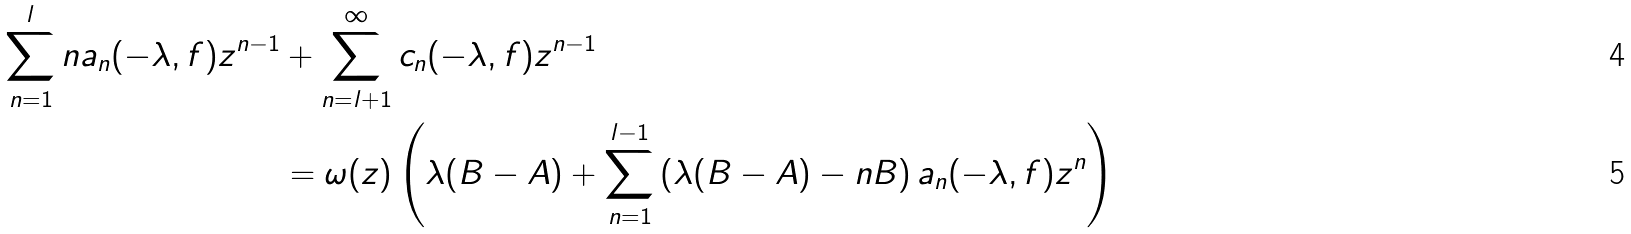<formula> <loc_0><loc_0><loc_500><loc_500>\sum _ { n = 1 } ^ { l } n a _ { n } ( - \lambda , f ) z ^ { n - 1 } & + \sum _ { n = l + 1 } ^ { \infty } c _ { n } ( - \lambda , f ) z ^ { n - 1 } \\ & = \omega ( z ) \left ( \lambda ( B - A ) + \sum _ { n = 1 } ^ { l - 1 } \left ( \lambda ( B - A ) - n B \right ) a _ { n } ( - \lambda , f ) z ^ { n } \right )</formula> 